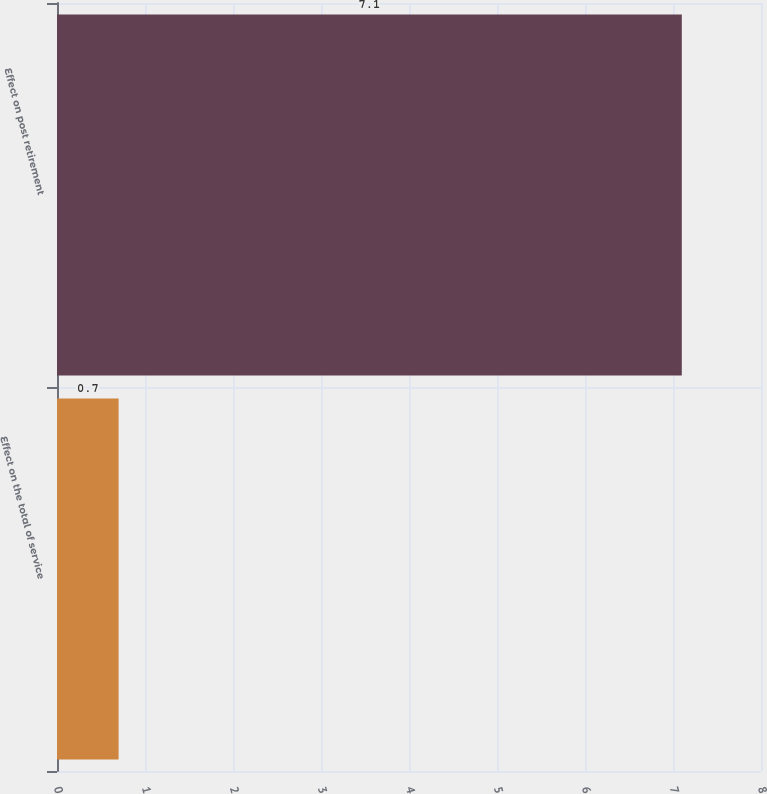Convert chart to OTSL. <chart><loc_0><loc_0><loc_500><loc_500><bar_chart><fcel>Effect on the total of service<fcel>Effect on post retirement<nl><fcel>0.7<fcel>7.1<nl></chart> 